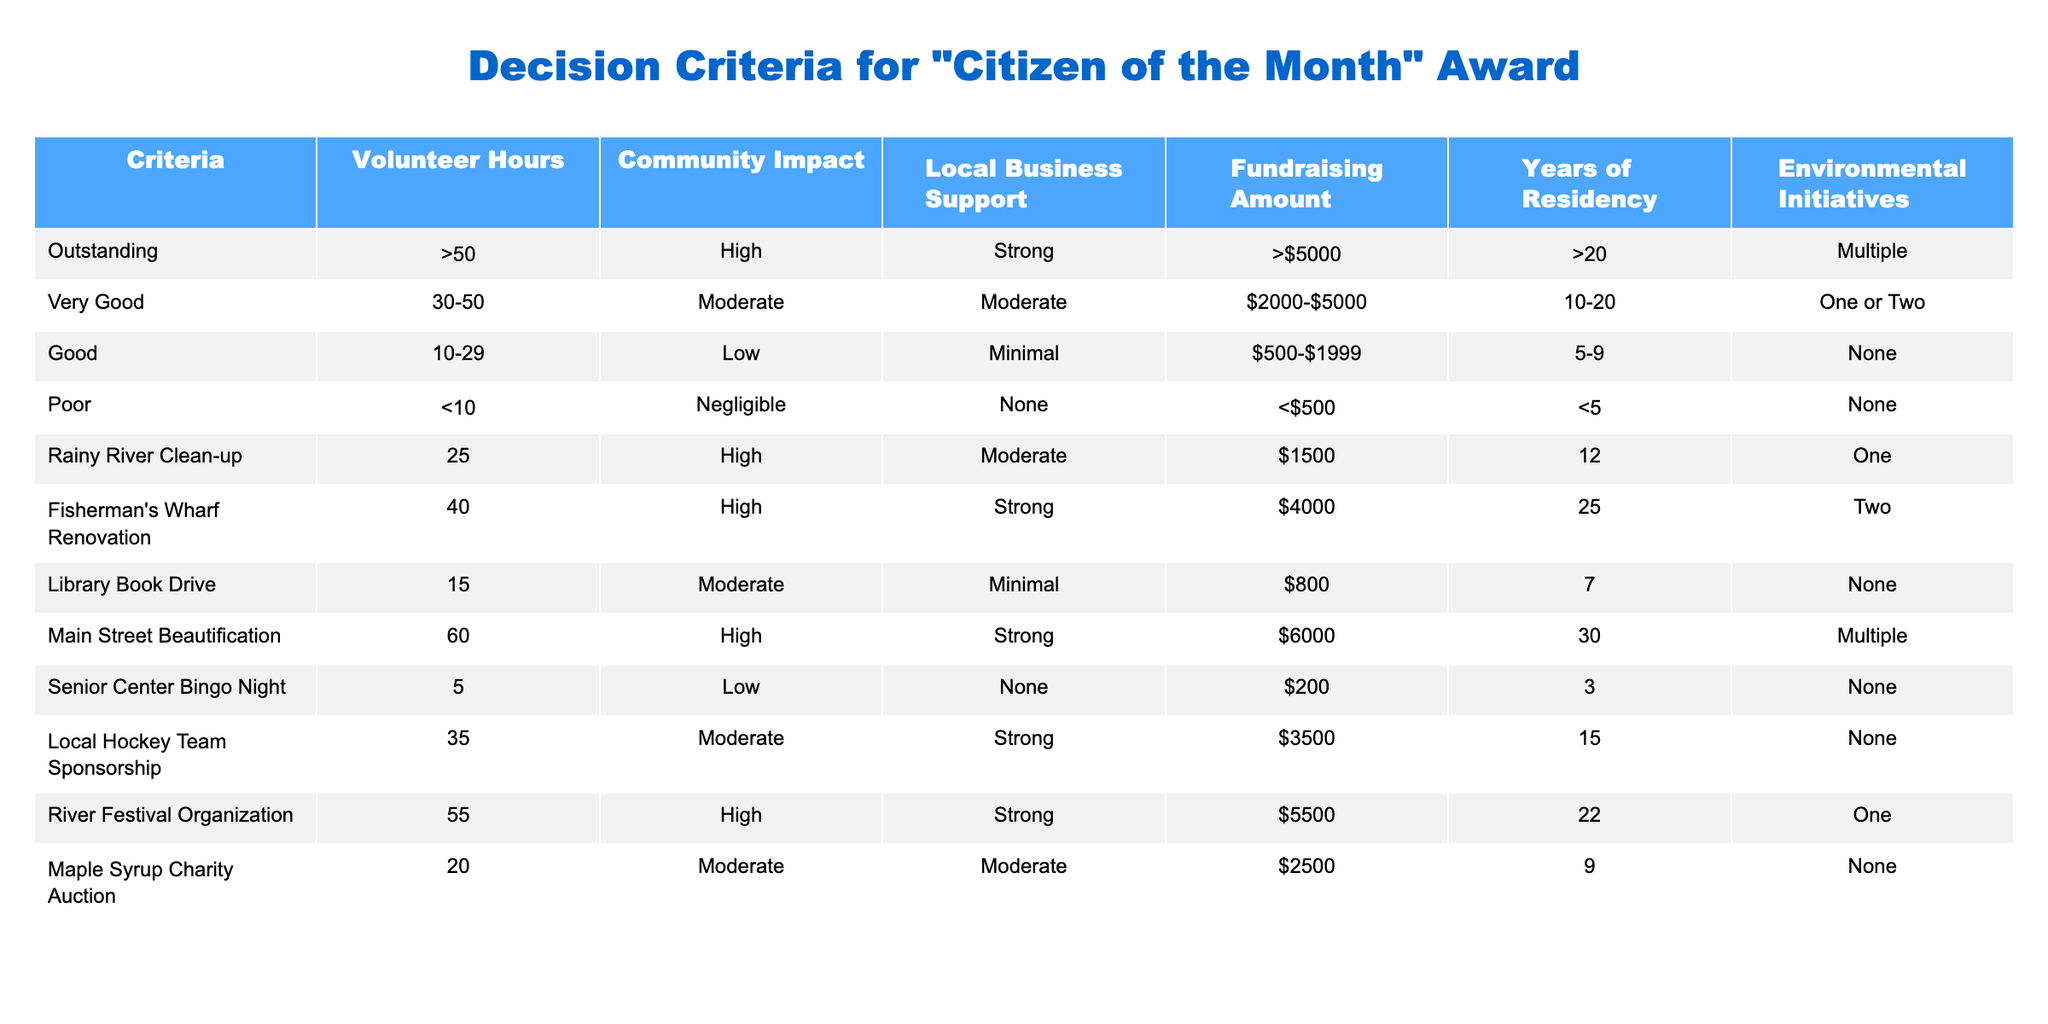What are the criteria for the "Citizen of the Month" award? The criteria include Volunteer Hours, Community Impact, Local Business Support, Fundraising Amount, Years of Residency, and Environmental Initiatives, as displayed in the table.
Answer: Volunteer Hours, Community Impact, Local Business Support, Fundraising Amount, Years of Residency, Environmental Initiatives Which initiative has the highest Volunteer Hours? By checking the Volunteer Hours column, "Main Street Beautification" is listed with 60 hours, which is the highest among all initiatives.
Answer: Main Street Beautification How many initiatives have a "High" Community Impact? Looking through the Community Impact column, the initiatives with "High" are Rainy River Clean-up, Fisherman's Wharf Renovation, Main Street Beautification, River Festival Organization. Counting these gives a total of 4 initiatives.
Answer: 4 Is the River Festival Organization eligible for an "Outstanding" award based on the criteria? The River Festival Organization shows 55 Volunteer Hours, which is more than 50, High Community Impact, Strong Local Business Support, Fundraising Amount of $5500, and 22 Years of Residency. Thus, it meets all criteria for "Outstanding."
Answer: Yes What is the average Fundraising Amount of the initiatives that have "Moderate" Local Business Support? From the initiatives with "Moderate" Local Business Support: Local Hockey Team Sponsorship ($3500), Maple Syrup Charity Auction ($2500), and Rainy River Clean-up ($1500). The average is calculated as (3500 + 2500 + 1500) / 3 = 2500.
Answer: 2500 Which initiative has the longest Years of Residency and what is its Community Impact rating? By checking the Years of Residency column, "Fisherman's Wharf Renovation" has the longest residency at 25 years. Its Community Impact is rated as "High."
Answer: 25 years, High Does any initiative with "Poor" criteria have any Volunteer Hours? Checking the criteria, the initiative "Senior Center Bingo Night" has only 5 Volunteer Hours which qualifies it as "Poor." Therefore, yes, there is an initiative with "Poor" and some Volunteer Hours.
Answer: Yes What is the total sum of Volunteer Hours for all initiatives eligible for the "Very Good" award? The initiatives eligible for "Very Good" are: Local Hockey Team Sponsorship (35), Maple Syrup Charity Auction (20), and Rainy River Clean-up (25). Summing these gives 35 + 20 + 25 = 80.
Answer: 80 